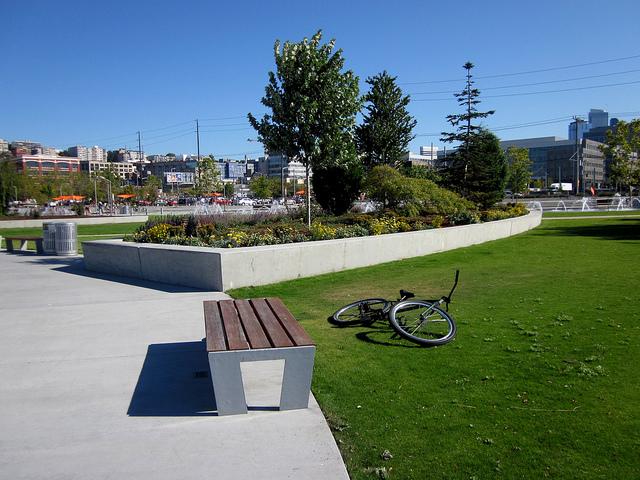How many benches are there?
Answer briefly. 2. Does the grass need to be cut?
Write a very short answer. No. Is this a urban area?
Short answer required. Yes. What is on the grass?
Give a very brief answer. Bike. How many benches are in the picture?
Be succinct. 2. 